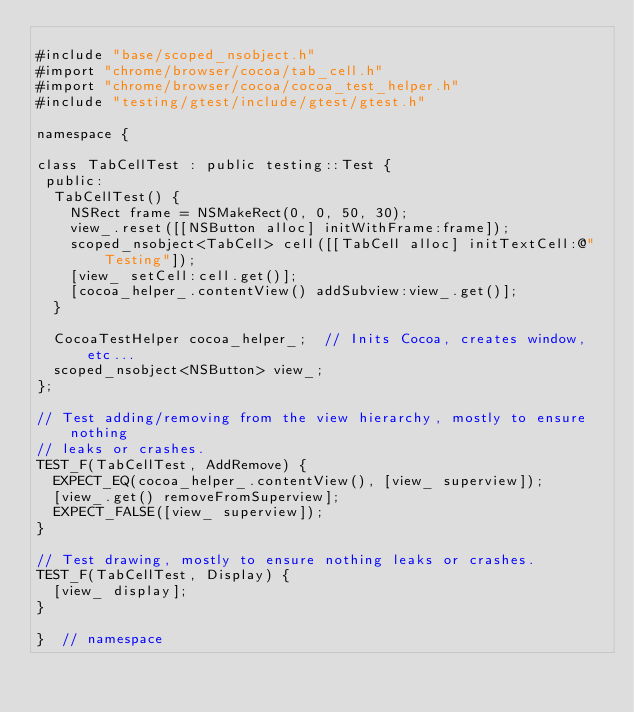Convert code to text. <code><loc_0><loc_0><loc_500><loc_500><_ObjectiveC_>
#include "base/scoped_nsobject.h"
#import "chrome/browser/cocoa/tab_cell.h"
#import "chrome/browser/cocoa/cocoa_test_helper.h"
#include "testing/gtest/include/gtest/gtest.h"

namespace {

class TabCellTest : public testing::Test {
 public:
  TabCellTest() {
    NSRect frame = NSMakeRect(0, 0, 50, 30);
    view_.reset([[NSButton alloc] initWithFrame:frame]);
    scoped_nsobject<TabCell> cell([[TabCell alloc] initTextCell:@"Testing"]);
    [view_ setCell:cell.get()];
    [cocoa_helper_.contentView() addSubview:view_.get()];
  }

  CocoaTestHelper cocoa_helper_;  // Inits Cocoa, creates window, etc...
  scoped_nsobject<NSButton> view_;
};

// Test adding/removing from the view hierarchy, mostly to ensure nothing
// leaks or crashes.
TEST_F(TabCellTest, AddRemove) {
  EXPECT_EQ(cocoa_helper_.contentView(), [view_ superview]);
  [view_.get() removeFromSuperview];
  EXPECT_FALSE([view_ superview]);
}

// Test drawing, mostly to ensure nothing leaks or crashes.
TEST_F(TabCellTest, Display) {
  [view_ display];
}

}  // namespace
</code> 